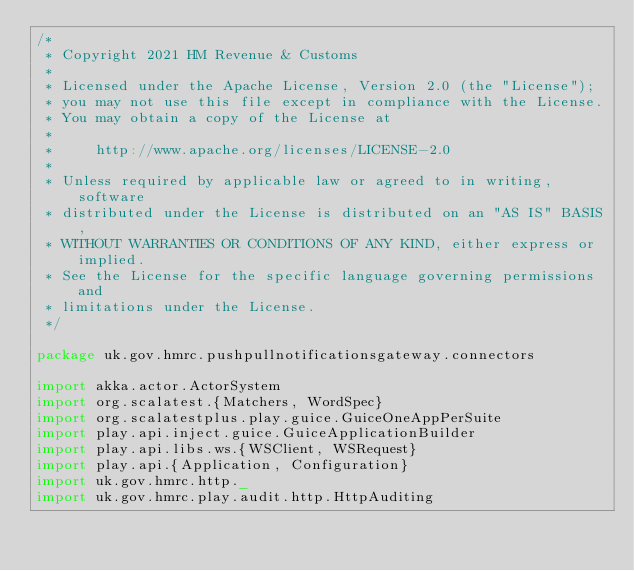<code> <loc_0><loc_0><loc_500><loc_500><_Scala_>/*
 * Copyright 2021 HM Revenue & Customs
 *
 * Licensed under the Apache License, Version 2.0 (the "License");
 * you may not use this file except in compliance with the License.
 * You may obtain a copy of the License at
 *
 *     http://www.apache.org/licenses/LICENSE-2.0
 *
 * Unless required by applicable law or agreed to in writing, software
 * distributed under the License is distributed on an "AS IS" BASIS,
 * WITHOUT WARRANTIES OR CONDITIONS OF ANY KIND, either express or implied.
 * See the License for the specific language governing permissions and
 * limitations under the License.
 */

package uk.gov.hmrc.pushpullnotificationsgateway.connectors

import akka.actor.ActorSystem
import org.scalatest.{Matchers, WordSpec}
import org.scalatestplus.play.guice.GuiceOneAppPerSuite
import play.api.inject.guice.GuiceApplicationBuilder
import play.api.libs.ws.{WSClient, WSRequest}
import play.api.{Application, Configuration}
import uk.gov.hmrc.http._
import uk.gov.hmrc.play.audit.http.HttpAuditing
</code> 